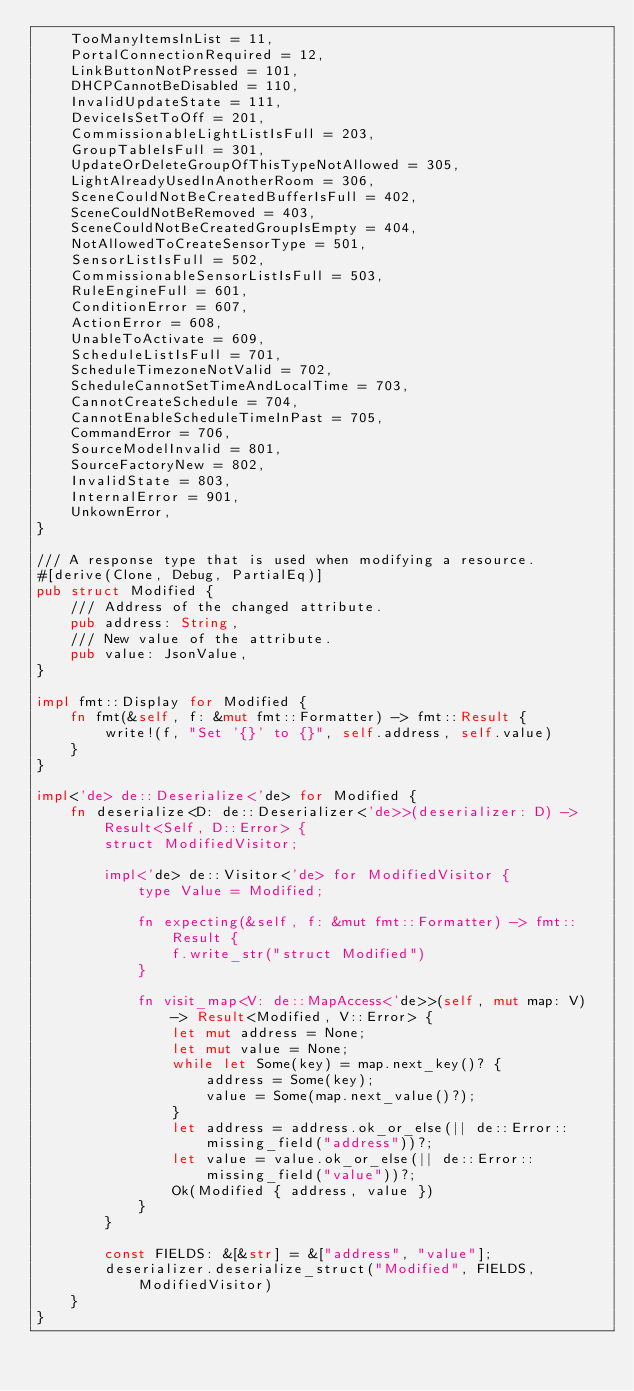<code> <loc_0><loc_0><loc_500><loc_500><_Rust_>    TooManyItemsInList = 11,
    PortalConnectionRequired = 12,
    LinkButtonNotPressed = 101,
    DHCPCannotBeDisabled = 110,
    InvalidUpdateState = 111,
    DeviceIsSetToOff = 201,
    CommissionableLightListIsFull = 203,
    GroupTableIsFull = 301,
    UpdateOrDeleteGroupOfThisTypeNotAllowed = 305,
    LightAlreadyUsedInAnotherRoom = 306,
    SceneCouldNotBeCreatedBufferIsFull = 402,
    SceneCouldNotBeRemoved = 403,
    SceneCouldNotBeCreatedGroupIsEmpty = 404,
    NotAllowedToCreateSensorType = 501,
    SensorListIsFull = 502,
    CommissionableSensorListIsFull = 503,
    RuleEngineFull = 601,
    ConditionError = 607,
    ActionError = 608,
    UnableToActivate = 609,
    ScheduleListIsFull = 701,
    ScheduleTimezoneNotValid = 702,
    ScheduleCannotSetTimeAndLocalTime = 703,
    CannotCreateSchedule = 704,
    CannotEnableScheduleTimeInPast = 705,
    CommandError = 706,
    SourceModelInvalid = 801,
    SourceFactoryNew = 802,
    InvalidState = 803,
    InternalError = 901,
    UnkownError,
}

/// A response type that is used when modifying a resource.
#[derive(Clone, Debug, PartialEq)]
pub struct Modified {
    /// Address of the changed attribute.
    pub address: String,
    /// New value of the attribute.
    pub value: JsonValue,
}

impl fmt::Display for Modified {
    fn fmt(&self, f: &mut fmt::Formatter) -> fmt::Result {
        write!(f, "Set '{}' to {}", self.address, self.value)
    }
}

impl<'de> de::Deserialize<'de> for Modified {
    fn deserialize<D: de::Deserializer<'de>>(deserializer: D) -> Result<Self, D::Error> {
        struct ModifiedVisitor;

        impl<'de> de::Visitor<'de> for ModifiedVisitor {
            type Value = Modified;

            fn expecting(&self, f: &mut fmt::Formatter) -> fmt::Result {
                f.write_str("struct Modified")
            }

            fn visit_map<V: de::MapAccess<'de>>(self, mut map: V) -> Result<Modified, V::Error> {
                let mut address = None;
                let mut value = None;
                while let Some(key) = map.next_key()? {
                    address = Some(key);
                    value = Some(map.next_value()?);
                }
                let address = address.ok_or_else(|| de::Error::missing_field("address"))?;
                let value = value.ok_or_else(|| de::Error::missing_field("value"))?;
                Ok(Modified { address, value })
            }
        }

        const FIELDS: &[&str] = &["address", "value"];
        deserializer.deserialize_struct("Modified", FIELDS, ModifiedVisitor)
    }
}
</code> 